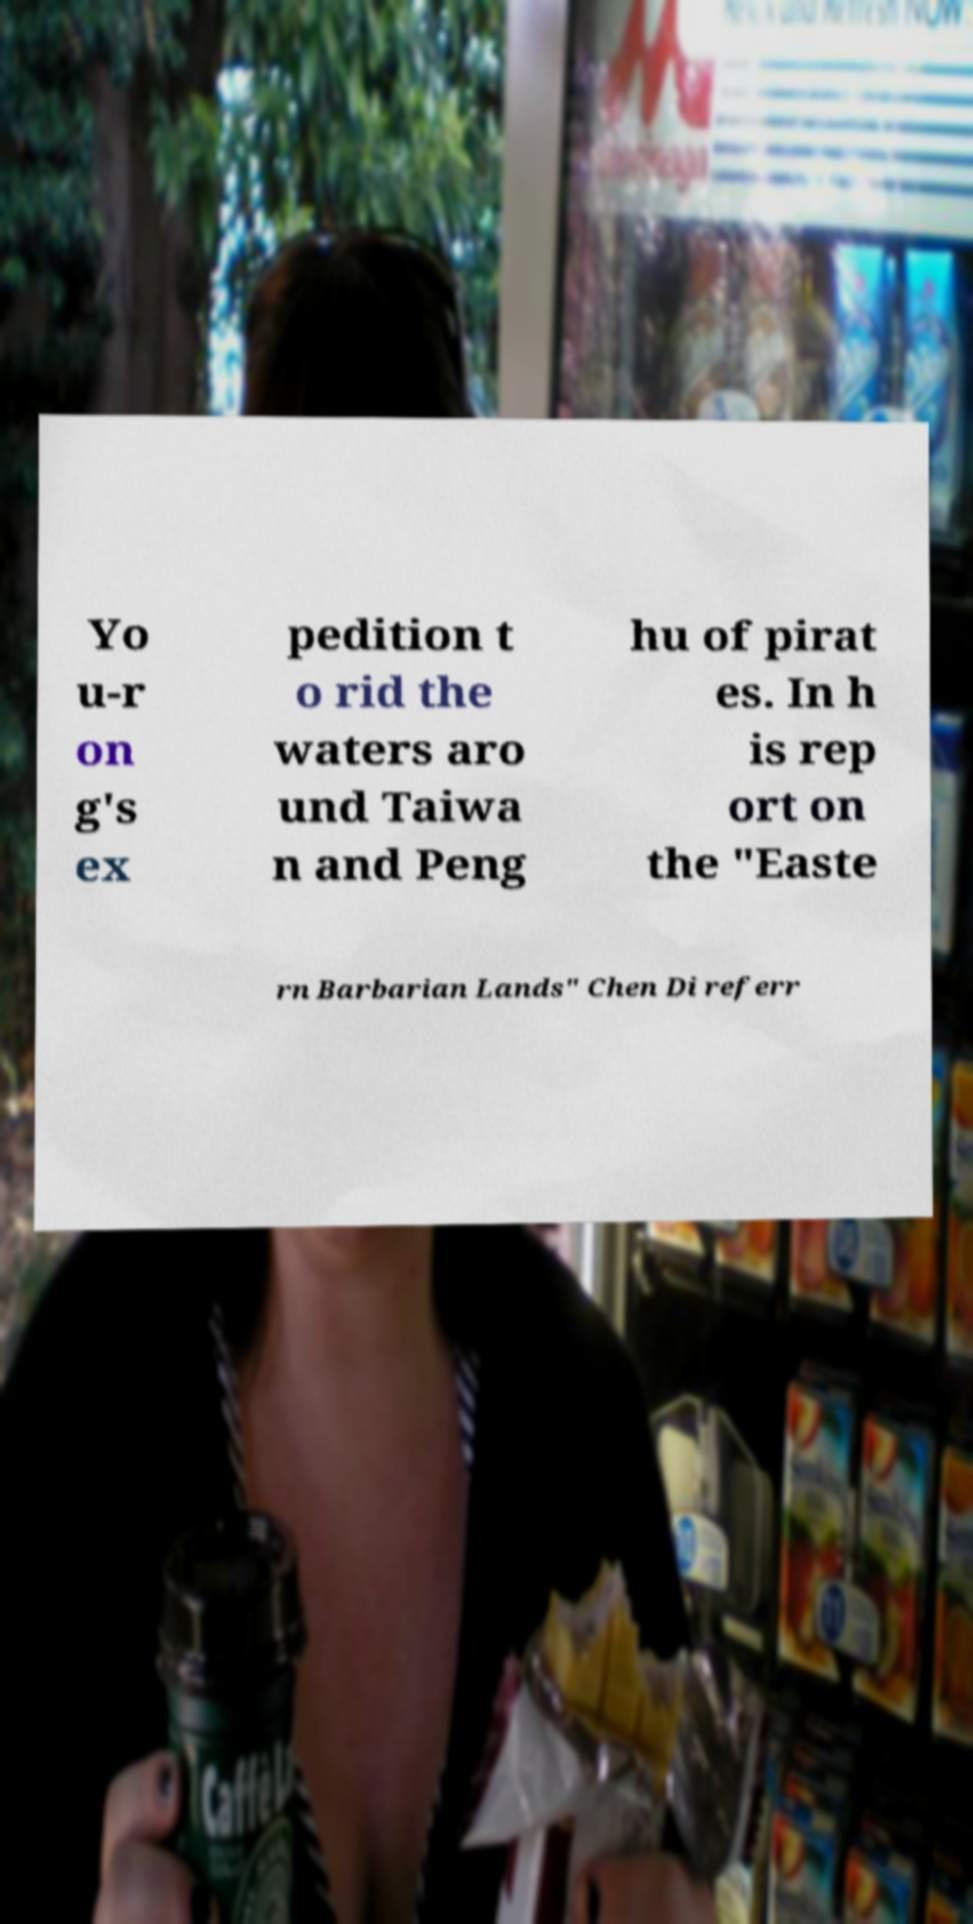I need the written content from this picture converted into text. Can you do that? Yo u-r on g's ex pedition t o rid the waters aro und Taiwa n and Peng hu of pirat es. In h is rep ort on the "Easte rn Barbarian Lands" Chen Di referr 